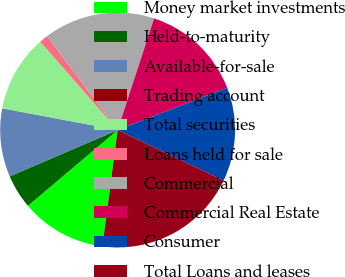<chart> <loc_0><loc_0><loc_500><loc_500><pie_chart><fcel>Money market investments<fcel>Held-to-maturity<fcel>Available-for-sale<fcel>Trading account<fcel>Total securities<fcel>Loans held for sale<fcel>Commercial<fcel>Commercial Real Estate<fcel>Consumer<fcel>Total Loans and leases<nl><fcel>11.76%<fcel>4.71%<fcel>9.41%<fcel>0.01%<fcel>10.59%<fcel>1.19%<fcel>15.29%<fcel>14.11%<fcel>12.94%<fcel>19.99%<nl></chart> 